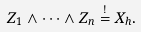<formula> <loc_0><loc_0><loc_500><loc_500>Z _ { 1 } \wedge \cdots \wedge Z _ { n } \stackrel { ! } { = } X _ { h } .</formula> 